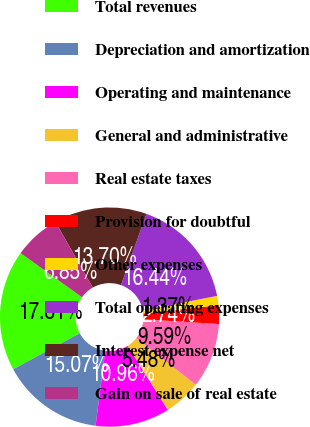Convert chart to OTSL. <chart><loc_0><loc_0><loc_500><loc_500><pie_chart><fcel>Total revenues<fcel>Depreciation and amortization<fcel>Operating and maintenance<fcel>General and administrative<fcel>Real estate taxes<fcel>Provision for doubtful<fcel>Other expenses<fcel>Total operating expenses<fcel>Interest expense net<fcel>Gain on sale of real estate<nl><fcel>17.81%<fcel>15.07%<fcel>10.96%<fcel>5.48%<fcel>9.59%<fcel>2.74%<fcel>1.37%<fcel>16.44%<fcel>13.7%<fcel>6.85%<nl></chart> 